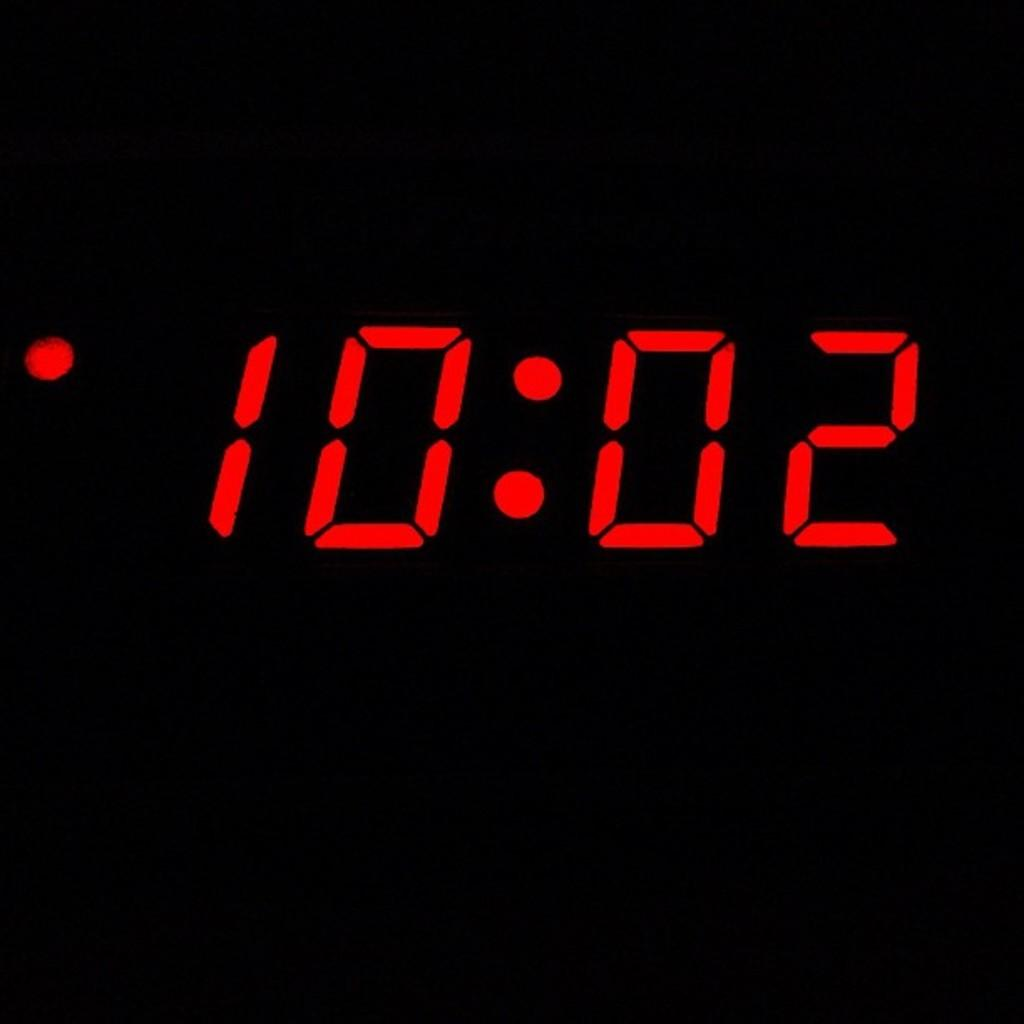<image>
Render a clear and concise summary of the photo. the time on the clock reads 10:02 in red 